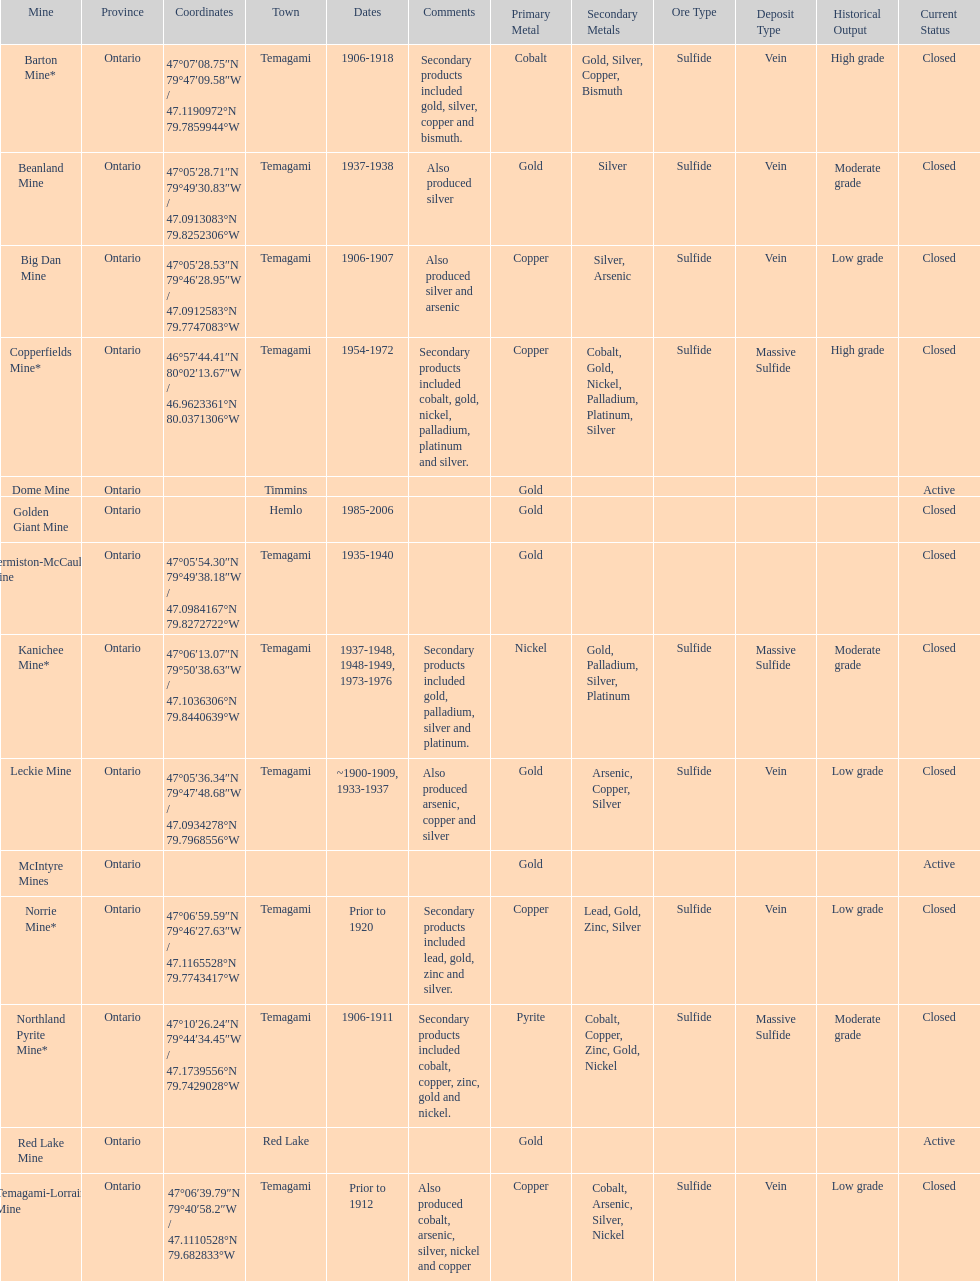In what mine could you find bismuth? Barton Mine. 